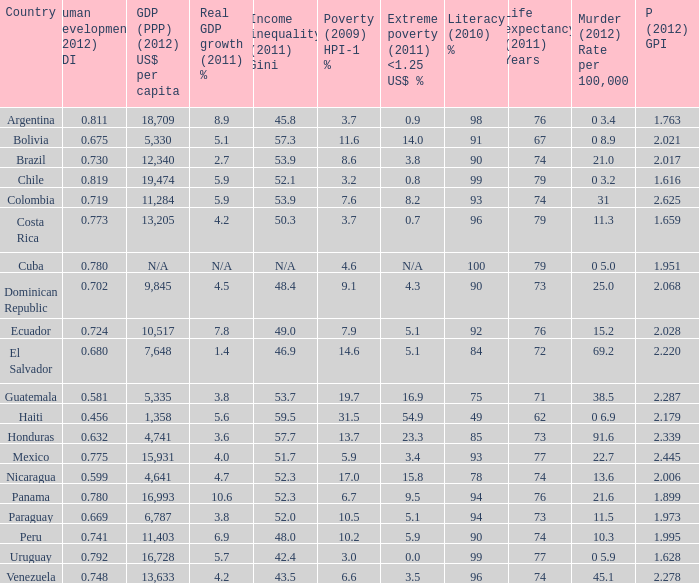What is the total poverty (2009) HPI-1 % when the extreme poverty (2011) <1.25 US$ % of 16.9, and the human development (2012) HDI is less than 0.581? None. 